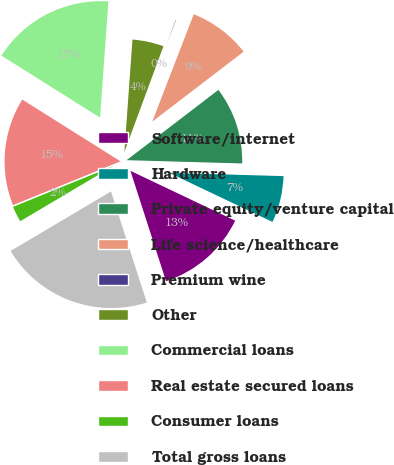Convert chart. <chart><loc_0><loc_0><loc_500><loc_500><pie_chart><fcel>Software/internet<fcel>Hardware<fcel>Private equity/venture capital<fcel>Life science/healthcare<fcel>Premium wine<fcel>Other<fcel>Commercial loans<fcel>Real estate secured loans<fcel>Consumer loans<fcel>Total gross loans<nl><fcel>12.97%<fcel>6.61%<fcel>10.85%<fcel>8.73%<fcel>0.24%<fcel>4.49%<fcel>17.21%<fcel>15.09%<fcel>2.36%<fcel>21.45%<nl></chart> 